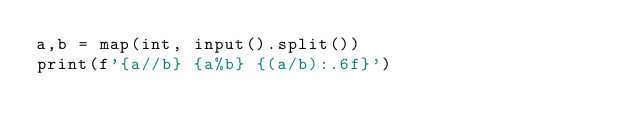Convert code to text. <code><loc_0><loc_0><loc_500><loc_500><_Python_>a,b = map(int, input().split())
print(f'{a//b} {a%b} {(a/b):.6f}')
</code> 